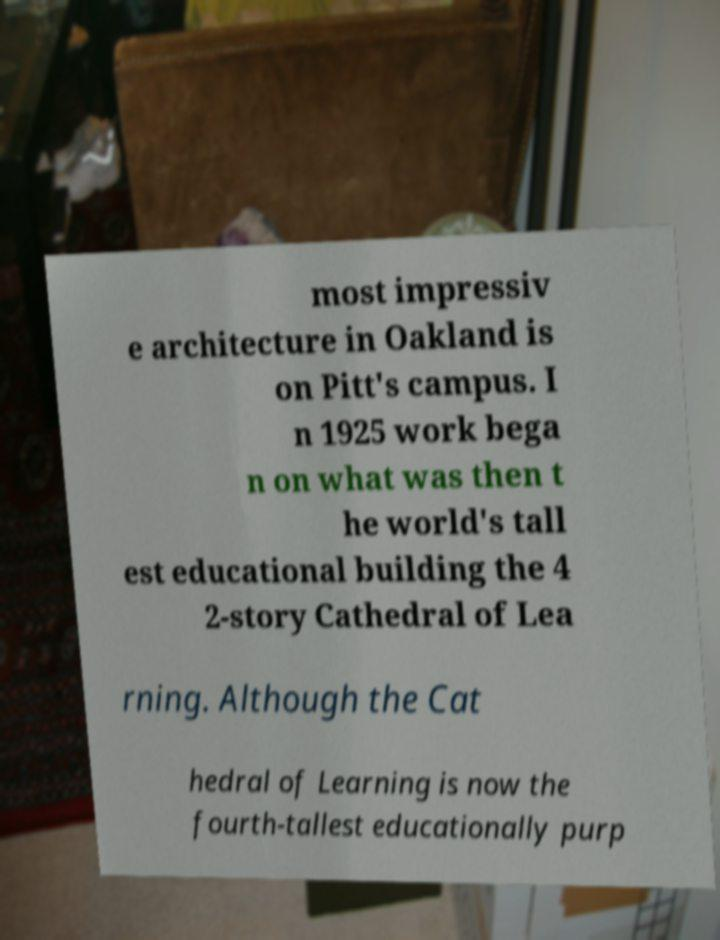Can you read and provide the text displayed in the image?This photo seems to have some interesting text. Can you extract and type it out for me? most impressiv e architecture in Oakland is on Pitt's campus. I n 1925 work bega n on what was then t he world's tall est educational building the 4 2-story Cathedral of Lea rning. Although the Cat hedral of Learning is now the fourth-tallest educationally purp 